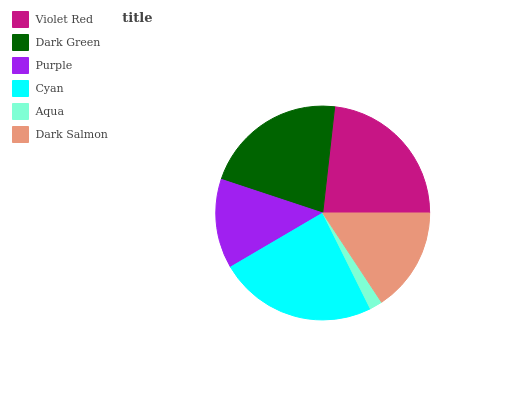Is Aqua the minimum?
Answer yes or no. Yes. Is Cyan the maximum?
Answer yes or no. Yes. Is Dark Green the minimum?
Answer yes or no. No. Is Dark Green the maximum?
Answer yes or no. No. Is Violet Red greater than Dark Green?
Answer yes or no. Yes. Is Dark Green less than Violet Red?
Answer yes or no. Yes. Is Dark Green greater than Violet Red?
Answer yes or no. No. Is Violet Red less than Dark Green?
Answer yes or no. No. Is Dark Green the high median?
Answer yes or no. Yes. Is Dark Salmon the low median?
Answer yes or no. Yes. Is Cyan the high median?
Answer yes or no. No. Is Cyan the low median?
Answer yes or no. No. 